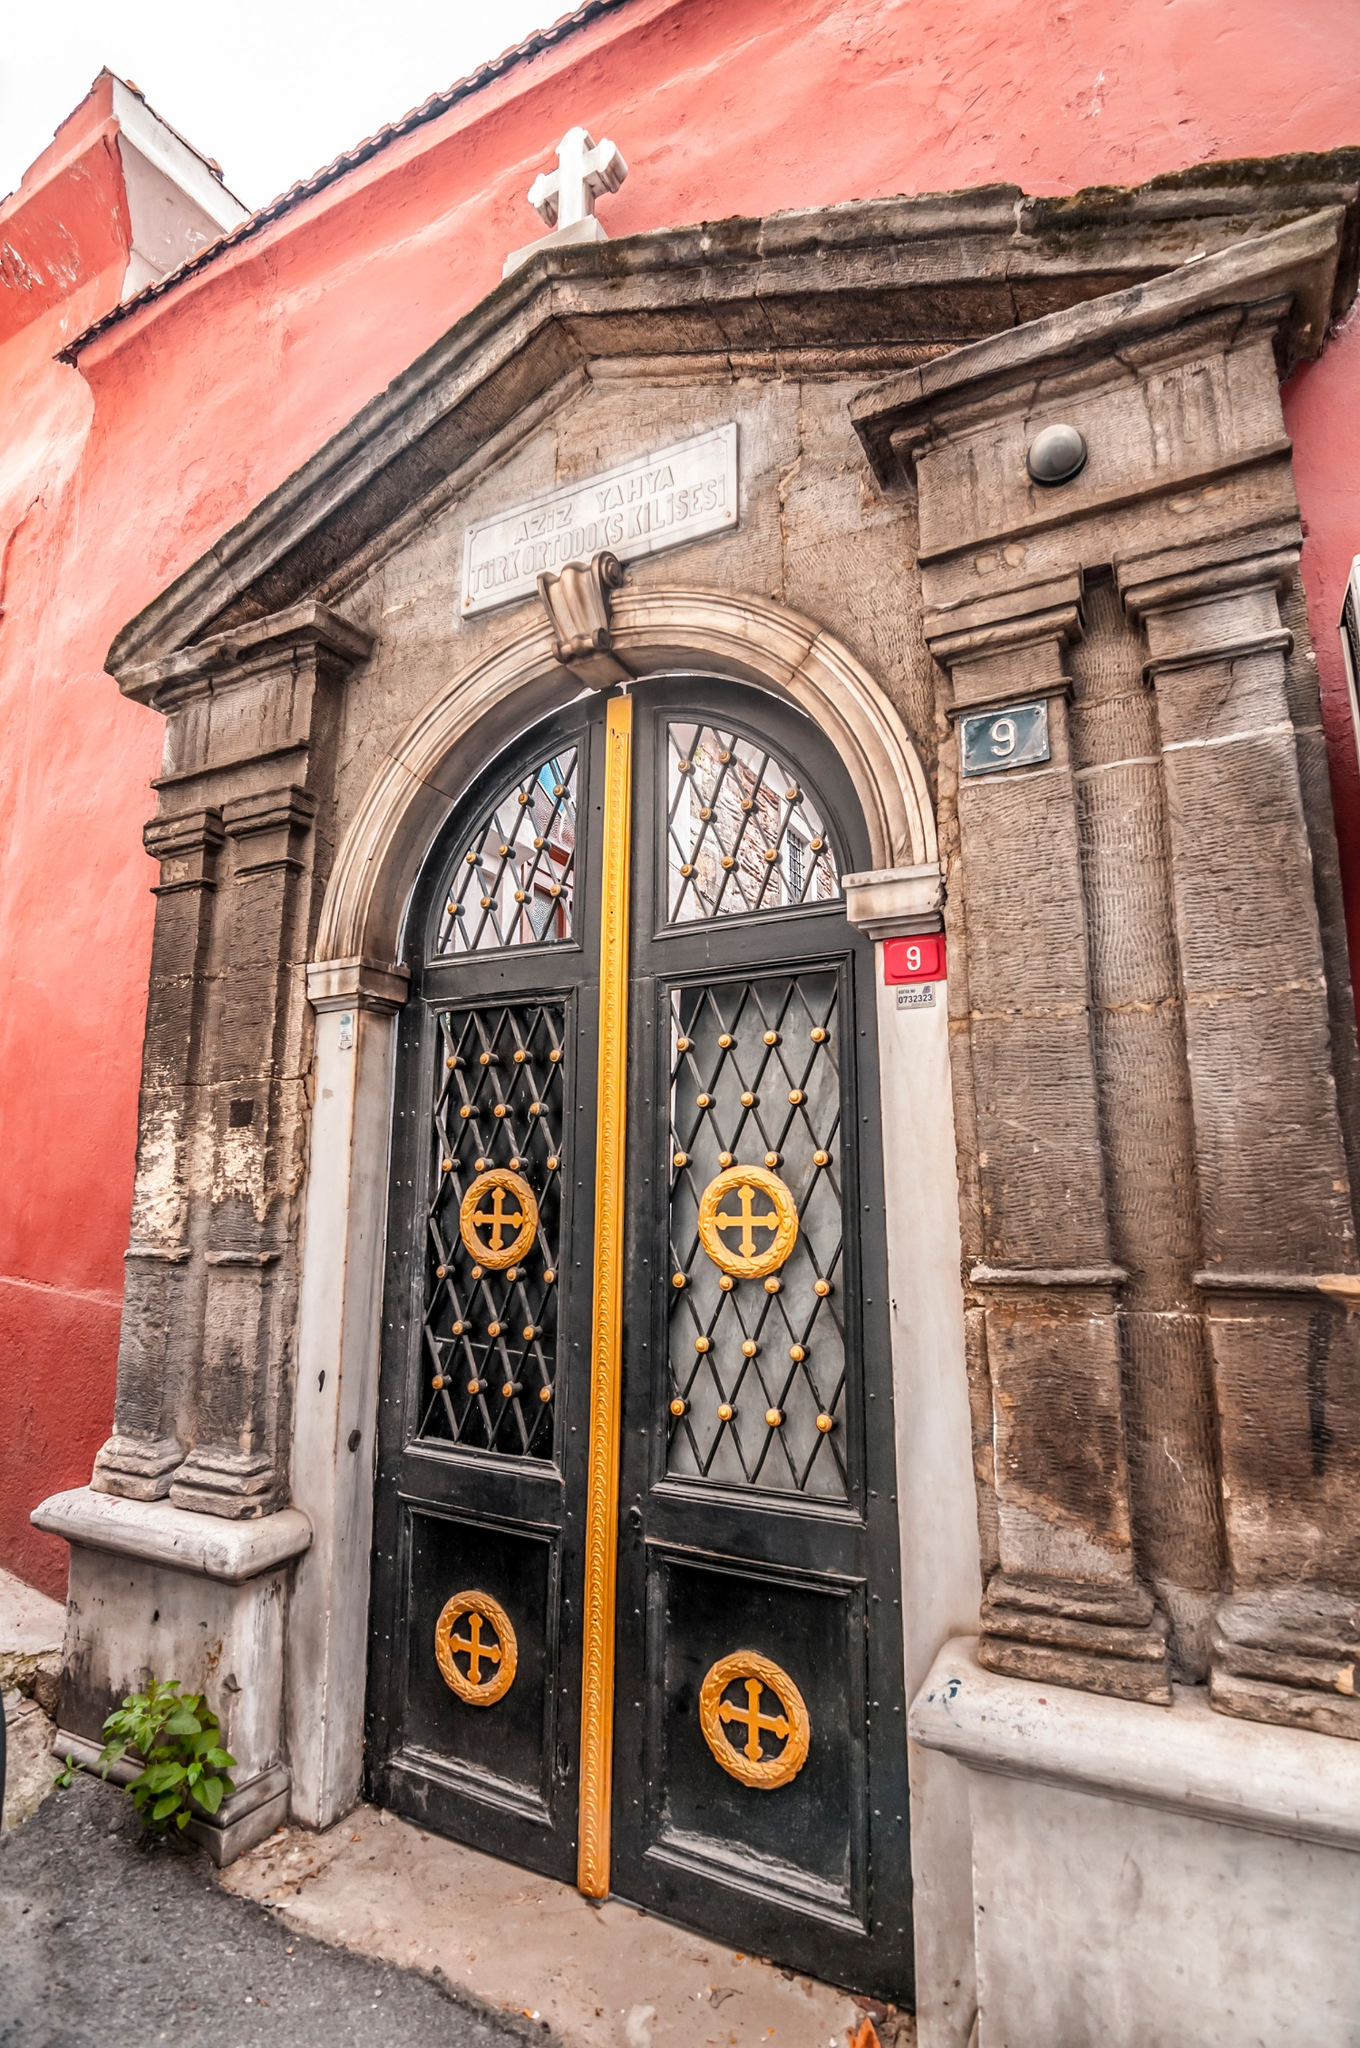Can you imagine a festive event taking place here and describe it? Picture a vibrant festival on a warm summer evening. The building is adorned with strings of twinkling lights and colorful banners. The air is filled with the sounds of traditional music and the aroma of freshly baked pastries. An outdoor service is held, with decorated icons placed on stands around the entrance. The community gathers in festive attire, singing hymns and participating in lively dances. Children hold lit candles, their faces glowing with joy. The festival continues late into the night, ending with a grand fireworks display that illuminates the sky and the long-standing walls of the building, creating a magical and unforgettable night. 